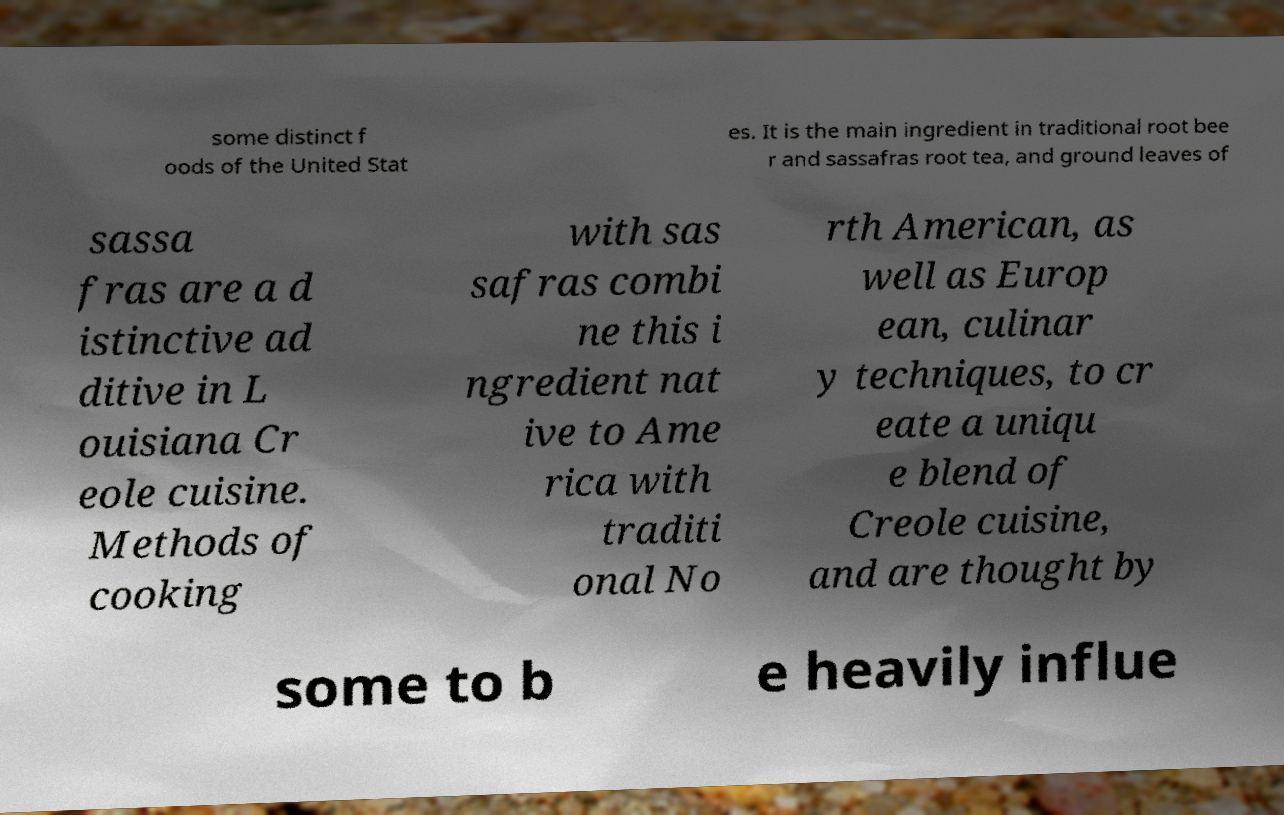Please read and relay the text visible in this image. What does it say? some distinct f oods of the United Stat es. It is the main ingredient in traditional root bee r and sassafras root tea, and ground leaves of sassa fras are a d istinctive ad ditive in L ouisiana Cr eole cuisine. Methods of cooking with sas safras combi ne this i ngredient nat ive to Ame rica with traditi onal No rth American, as well as Europ ean, culinar y techniques, to cr eate a uniqu e blend of Creole cuisine, and are thought by some to b e heavily influe 